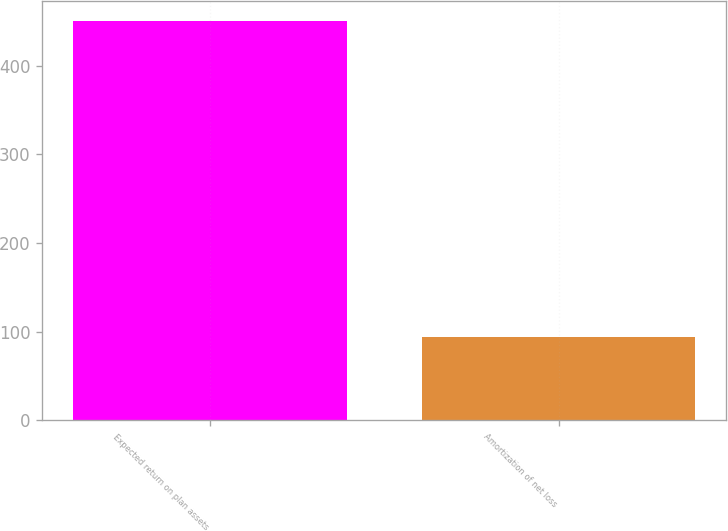<chart> <loc_0><loc_0><loc_500><loc_500><bar_chart><fcel>Expected return on plan assets<fcel>Amortization of net loss<nl><fcel>450<fcel>94<nl></chart> 